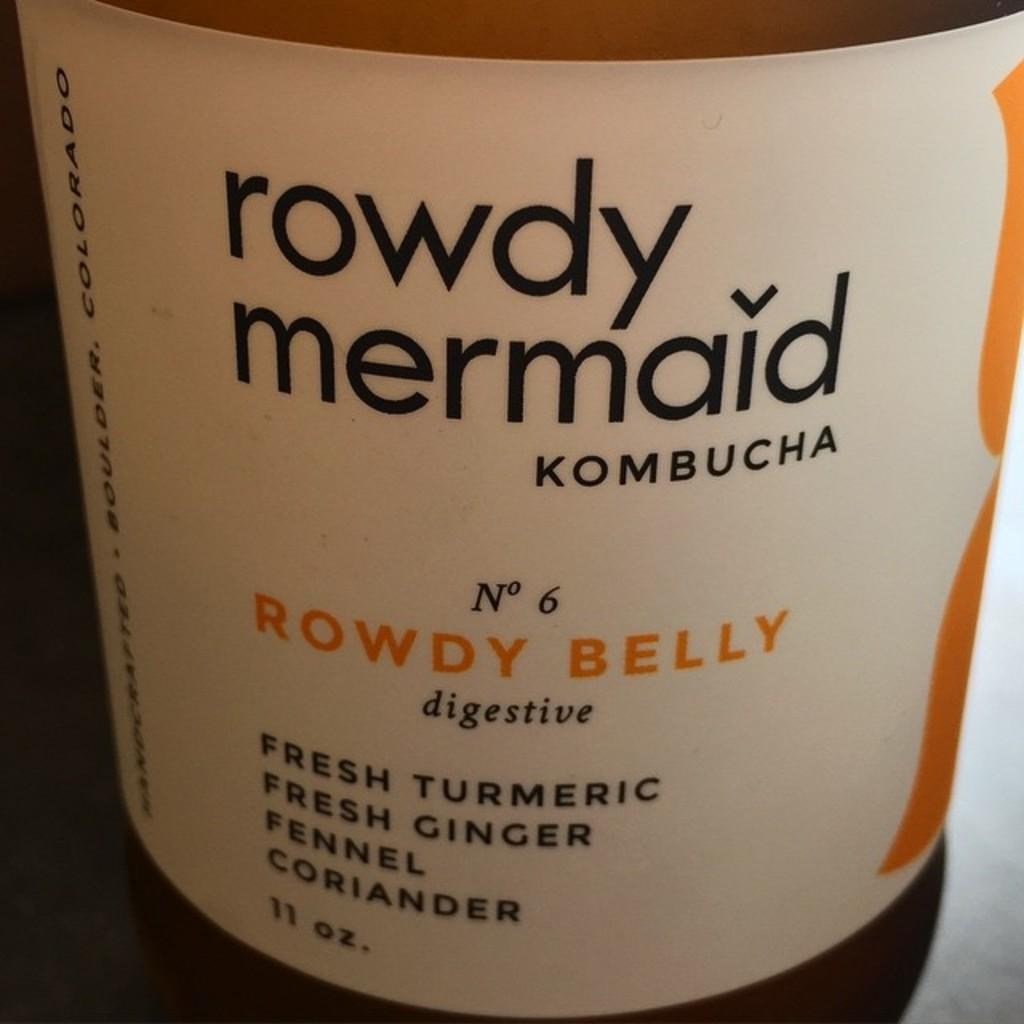<image>
Summarize the visual content of the image. A closeup of the label of Rowdy Mermaid Kombucha 